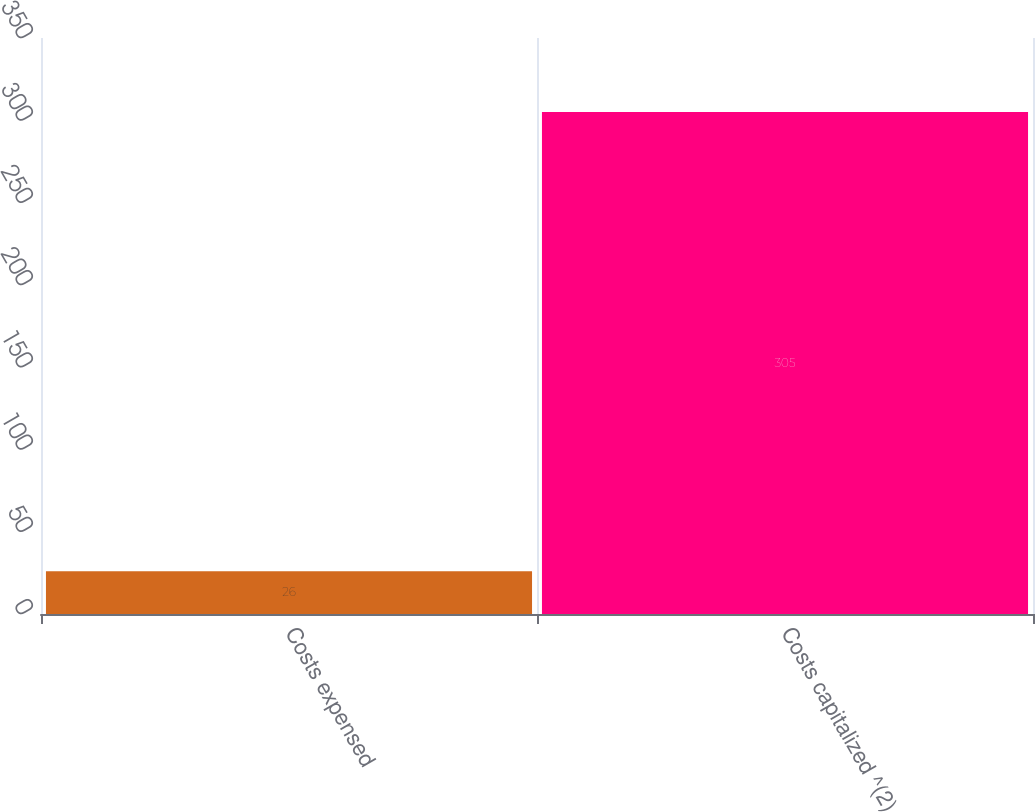<chart> <loc_0><loc_0><loc_500><loc_500><bar_chart><fcel>Costs expensed<fcel>Costs capitalized ^(2)<nl><fcel>26<fcel>305<nl></chart> 